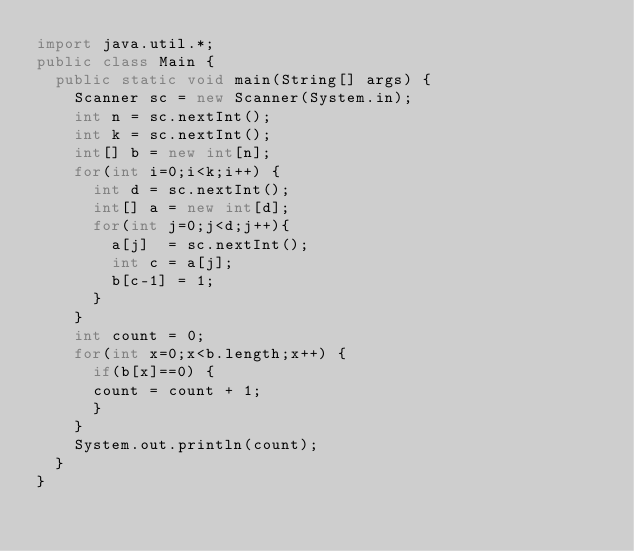Convert code to text. <code><loc_0><loc_0><loc_500><loc_500><_Java_>import java.util.*;
public class Main {
  public static void main(String[] args) {
    Scanner sc = new Scanner(System.in);
    int n = sc.nextInt();
    int k = sc.nextInt();
    int[] b = new int[n];
    for(int i=0;i<k;i++) {
      int d = sc.nextInt();
      int[] a = new int[d];
      for(int j=0;j<d;j++){
        a[j]  = sc.nextInt();
        int c = a[j];
		b[c-1] = 1;
      }      
    }
    int count = 0;
    for(int x=0;x<b.length;x++) {
      if(b[x]==0) {
      count = count + 1;
      }
    }
    System.out.println(count);
  }
}
</code> 